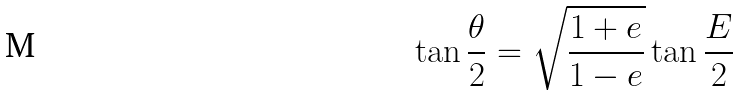Convert formula to latex. <formula><loc_0><loc_0><loc_500><loc_500>\tan { \frac { \theta } { 2 } } = { \sqrt { \frac { 1 + e } { 1 - e } } } \tan { \frac { E } { 2 } }</formula> 